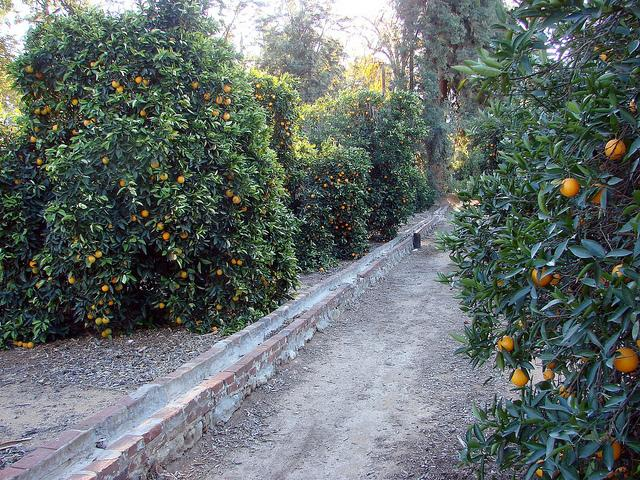What weather is greatest threat to this crop? Please explain your reasoning. freezing. Because it inhabits the growth of the crop which requires warmth to grow. 